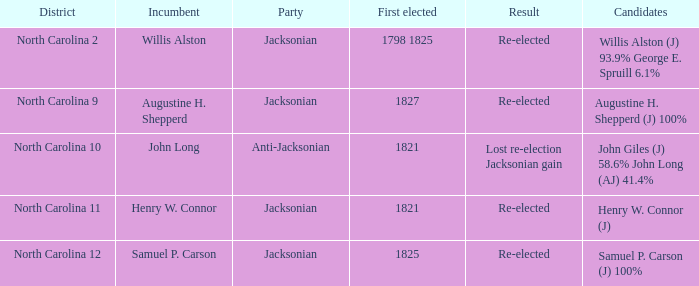What is the complete sum of party for willis alston (j) 9 1.0. 